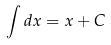<formula> <loc_0><loc_0><loc_500><loc_500>\int d x = x + C</formula> 